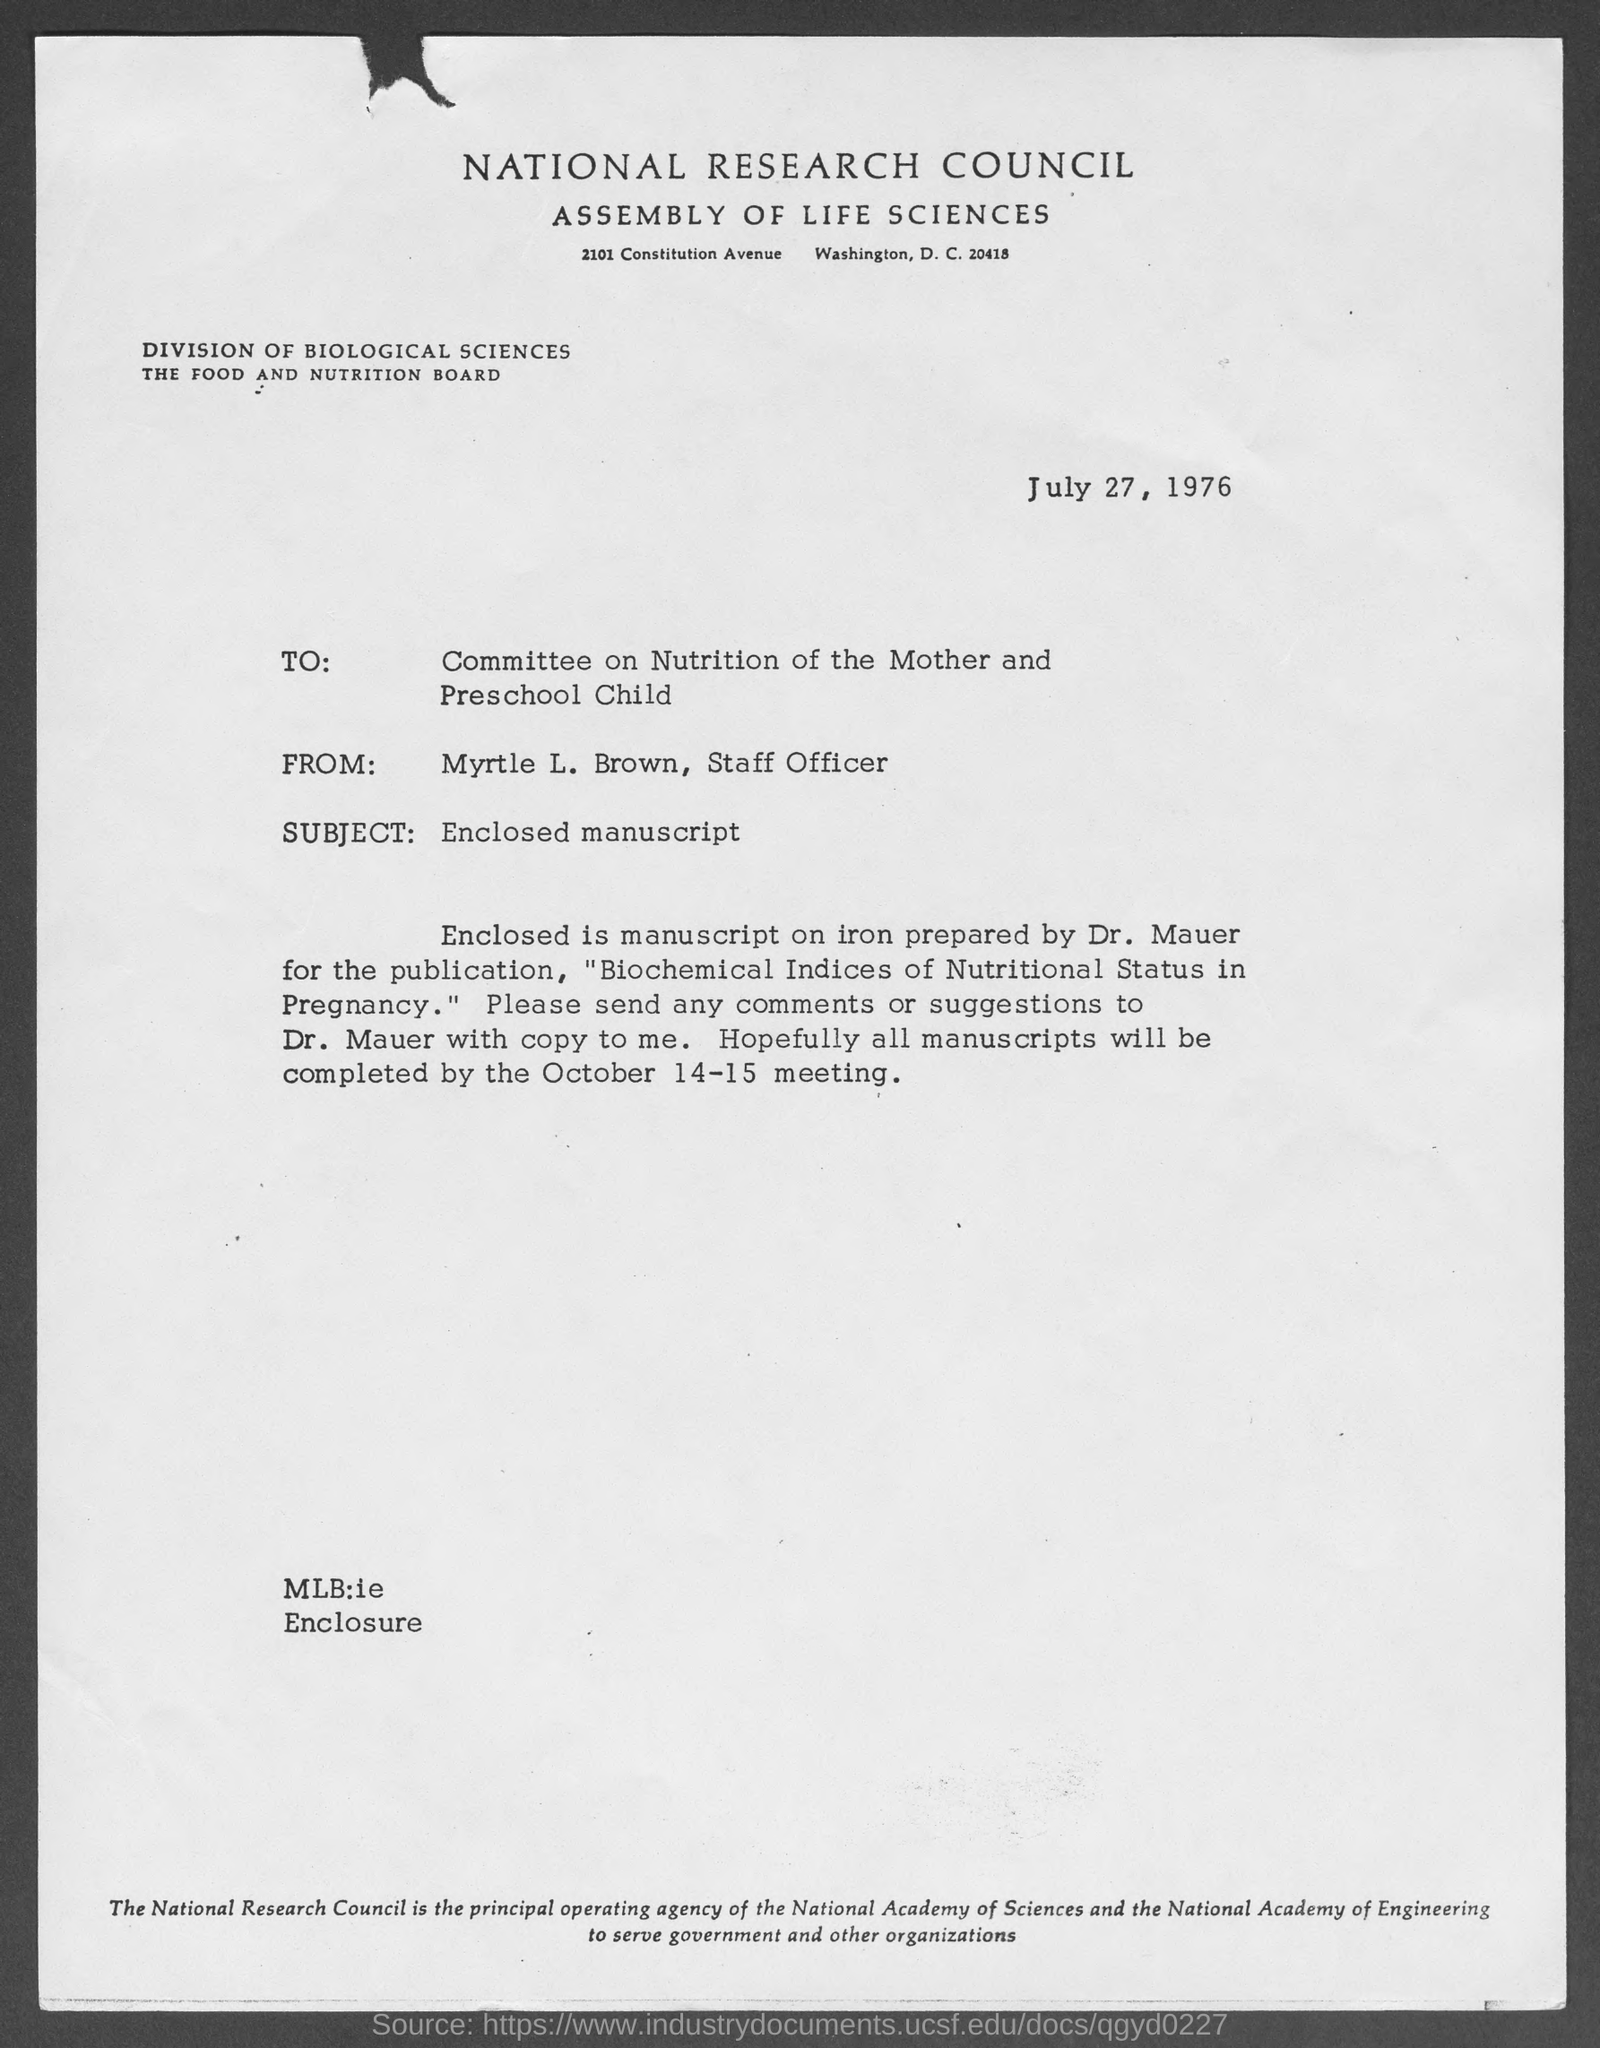What is the street address of national research council assembly of life sciences ?
Your response must be concise. 2101 Constitution Avenue  Washington, D.C. 20418. When is the memorandum dated?
Your answer should be compact. July 27, 1976. What is the subject of memorandum ?
Give a very brief answer. Enclosed manuscript. What is the position of myrtle l. brown ?
Offer a very short reply. Staff Officer. 